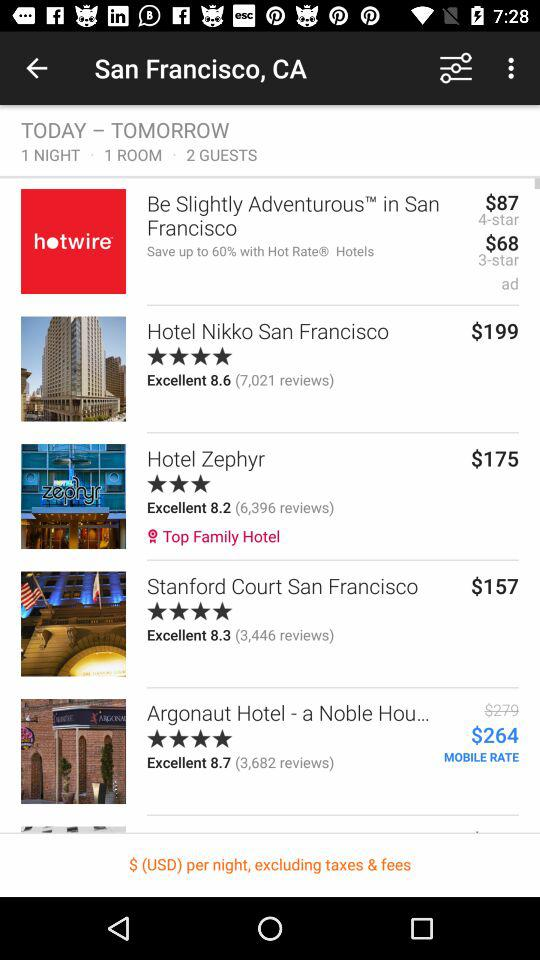How many beds are there for 2 guests?
When the provided information is insufficient, respond with <no answer>. <no answer> 